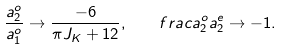Convert formula to latex. <formula><loc_0><loc_0><loc_500><loc_500>\frac { a _ { 2 } ^ { o } } { a _ { 1 } ^ { o } } \to \frac { - 6 } { \pi J _ { K } + 1 2 } , \quad f r a c { a _ { 2 } ^ { o } } { a _ { 2 } ^ { e } } \to - 1 .</formula> 